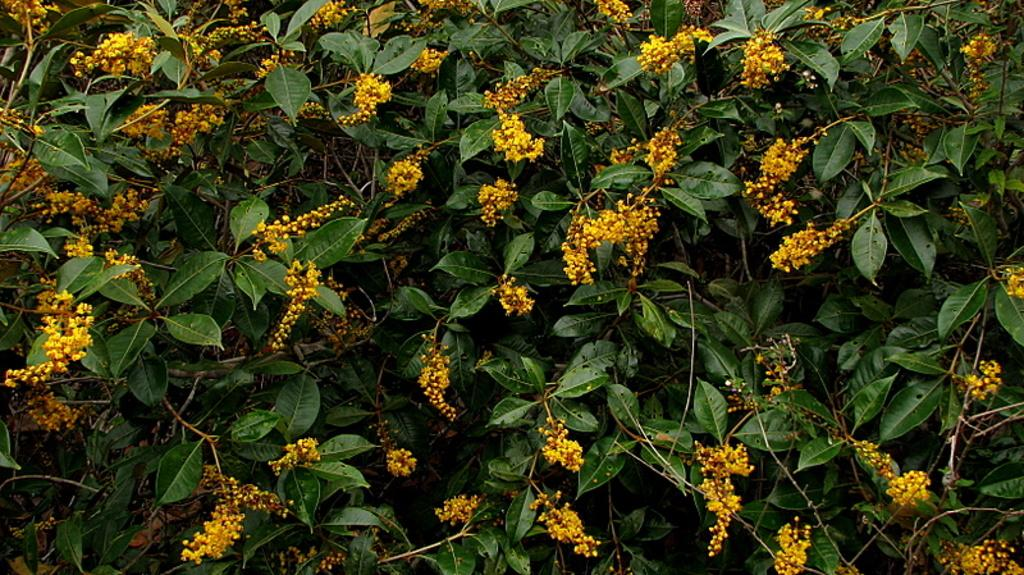What type of living organisms can be seen in the image? Plants can be seen in the image. What specific feature of the plants is visible in the image? The plants have flowers. What type of tool is being used by the fireman to open the clam in the image? There is no fireman, clam, or tool present in the image. The image only features plants with flowers. 